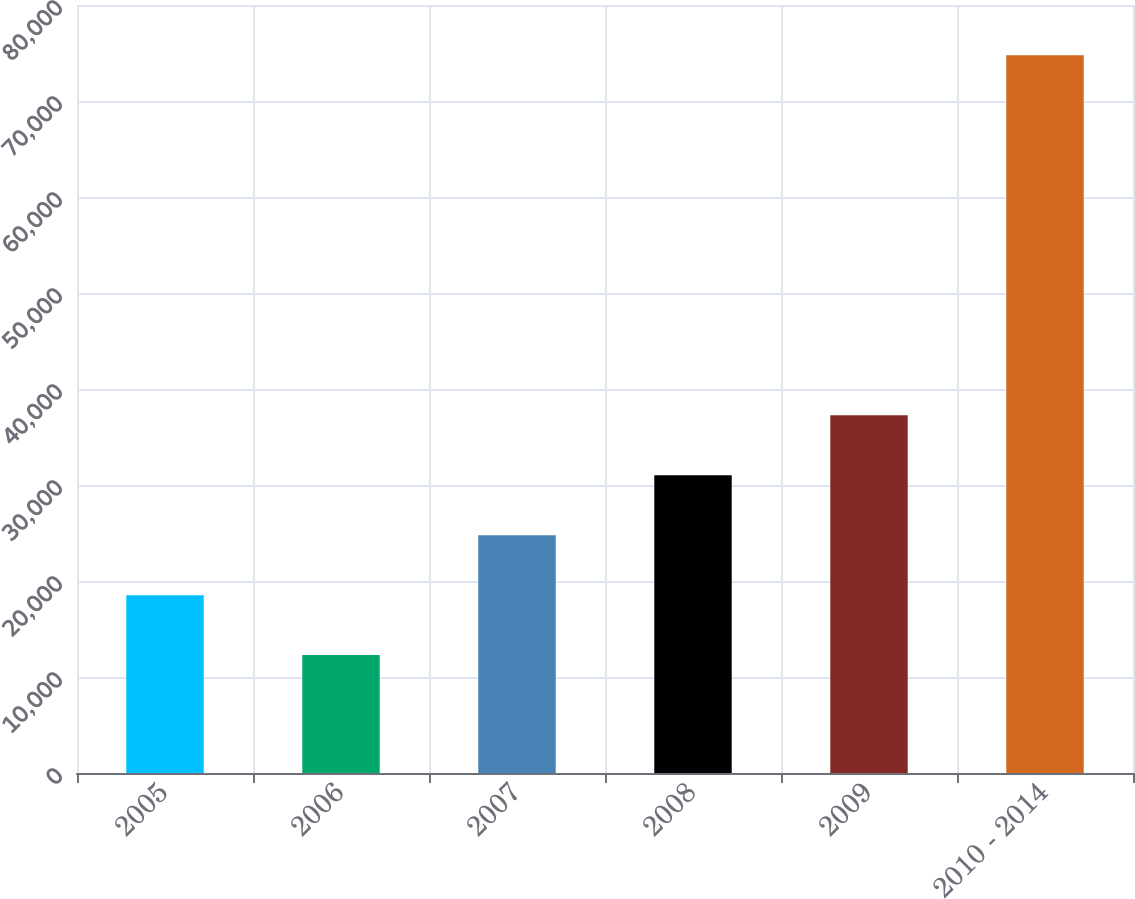Convert chart to OTSL. <chart><loc_0><loc_0><loc_500><loc_500><bar_chart><fcel>2005<fcel>2006<fcel>2007<fcel>2008<fcel>2009<fcel>2010 - 2014<nl><fcel>18527.5<fcel>12280<fcel>24775<fcel>31022.5<fcel>37270<fcel>74755<nl></chart> 